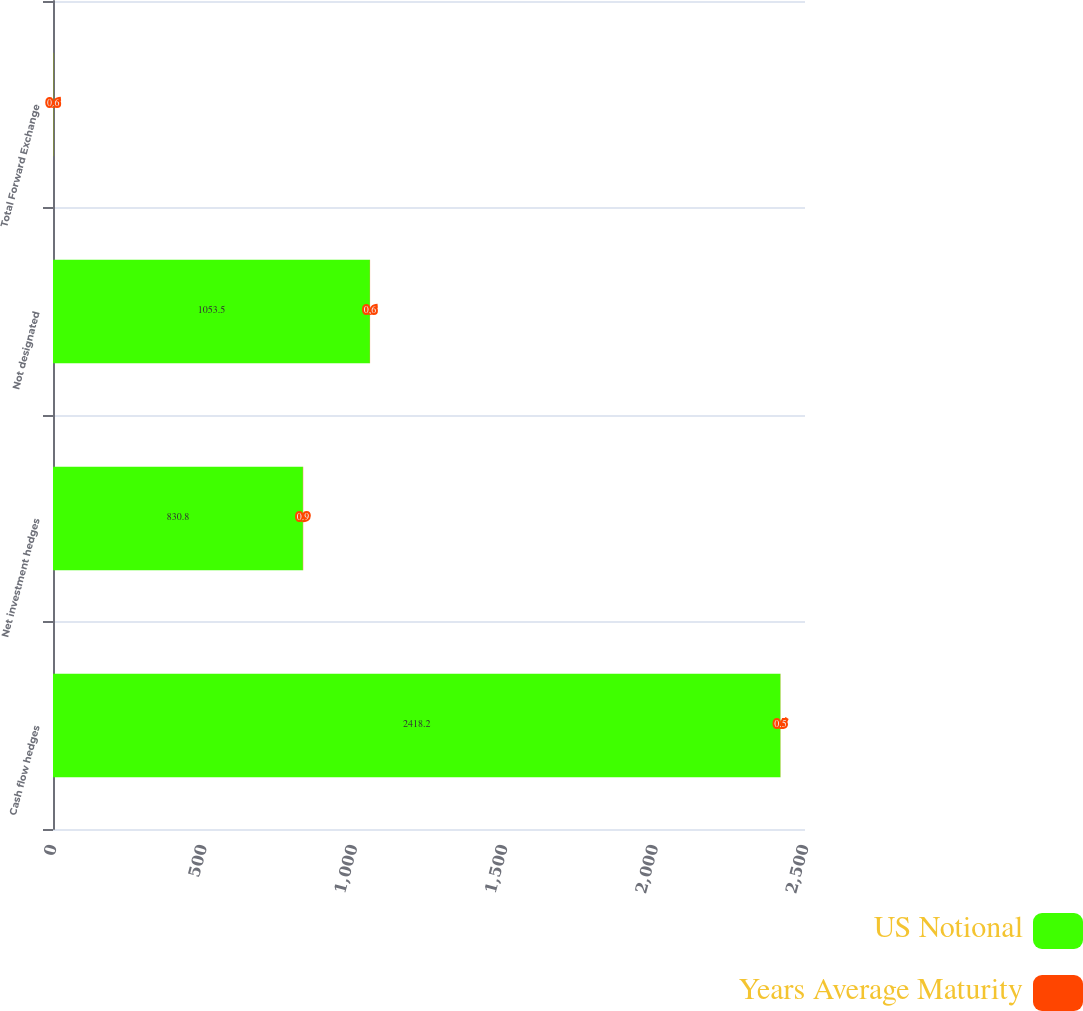<chart> <loc_0><loc_0><loc_500><loc_500><stacked_bar_chart><ecel><fcel>Cash flow hedges<fcel>Net investment hedges<fcel>Not designated<fcel>Total Forward Exchange<nl><fcel>US Notional<fcel>2418.2<fcel>830.8<fcel>1053.5<fcel>0.9<nl><fcel>Years Average Maturity<fcel>0.5<fcel>0.9<fcel>0.6<fcel>0.6<nl></chart> 